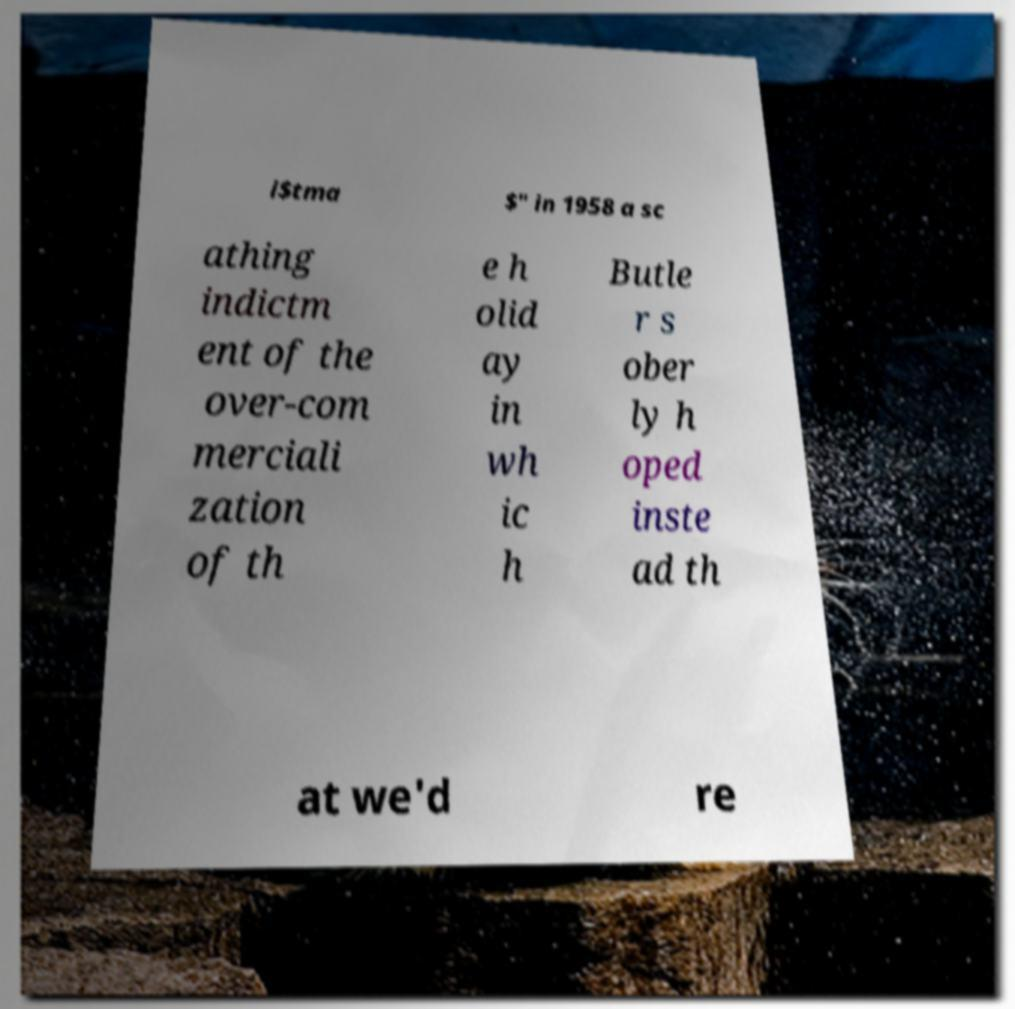Please read and relay the text visible in this image. What does it say? i$tma $" in 1958 a sc athing indictm ent of the over-com merciali zation of th e h olid ay in wh ic h Butle r s ober ly h oped inste ad th at we'd re 